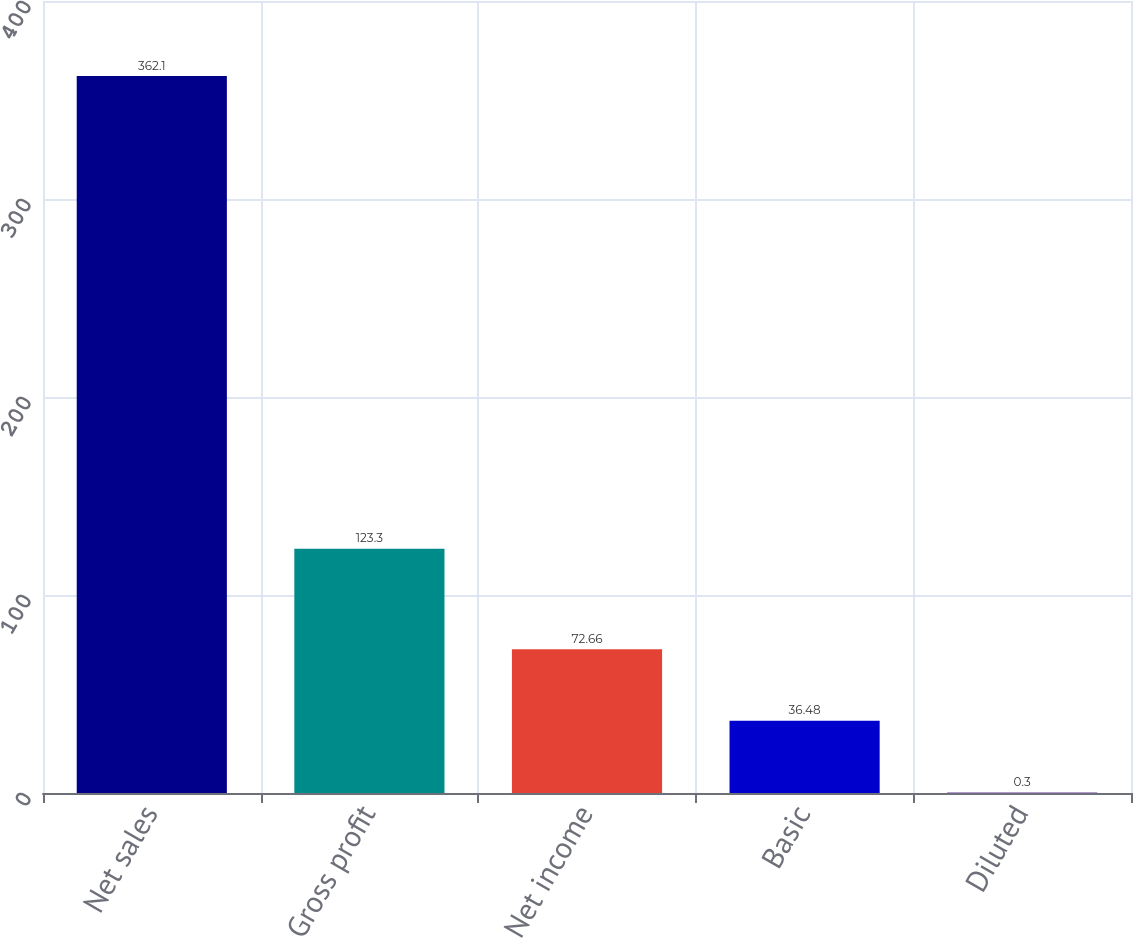Convert chart to OTSL. <chart><loc_0><loc_0><loc_500><loc_500><bar_chart><fcel>Net sales<fcel>Gross profit<fcel>Net income<fcel>Basic<fcel>Diluted<nl><fcel>362.1<fcel>123.3<fcel>72.66<fcel>36.48<fcel>0.3<nl></chart> 